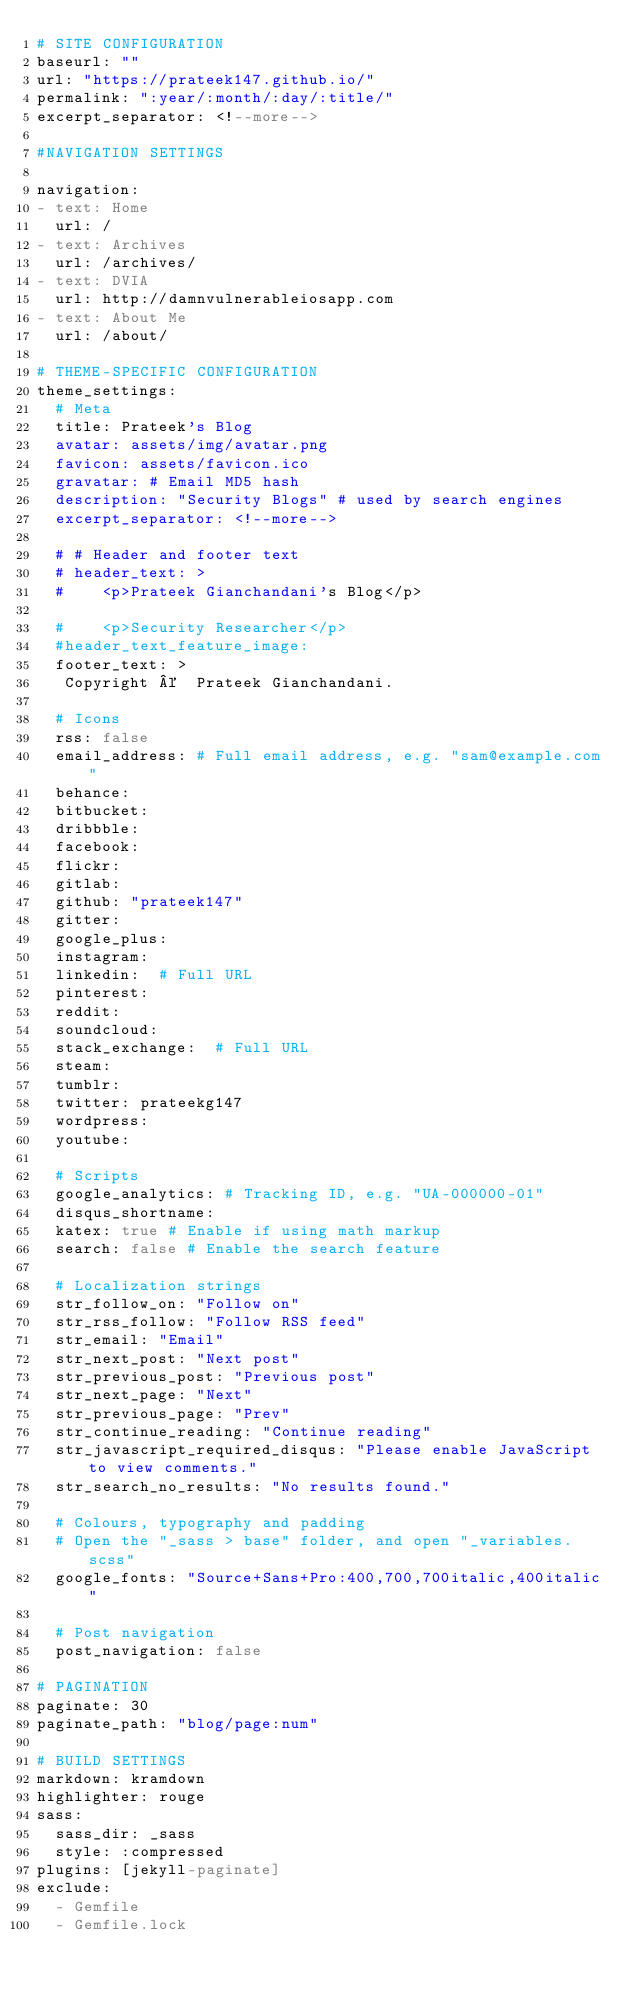<code> <loc_0><loc_0><loc_500><loc_500><_YAML_># SITE CONFIGURATION
baseurl: ""
url: "https://prateek147.github.io/"
permalink: ":year/:month/:day/:title/"
excerpt_separator: <!--more-->

#NAVIGATION SETTINGS

navigation:
- text: Home
  url: /
- text: Archives
  url: /archives/
- text: DVIA
  url: http://damnvulnerableiosapp.com
- text: About Me
  url: /about/

# THEME-SPECIFIC CONFIGURATION
theme_settings:
  # Meta
  title: Prateek's Blog
  avatar: assets/img/avatar.png
  favicon: assets/favicon.ico
  gravatar: # Email MD5 hash
  description: "Security Blogs" # used by search engines
  excerpt_separator: <!--more-->

  # # Header and footer text
  # header_text: >
  #    <p>Prateek Gianchandani's Blog</p>

  #    <p>Security Researcher</p>
  #header_text_feature_image:
  footer_text: >
   Copyright ©  Prateek Gianchandani.

  # Icons
  rss: false
  email_address: # Full email address, e.g. "sam@example.com"
  behance:
  bitbucket:
  dribbble:
  facebook:
  flickr:
  gitlab:
  github: "prateek147"
  gitter:
  google_plus:
  instagram:
  linkedin:  # Full URL
  pinterest:
  reddit:
  soundcloud:
  stack_exchange:  # Full URL
  steam:
  tumblr:
  twitter: prateekg147
  wordpress:
  youtube:

  # Scripts
  google_analytics: # Tracking ID, e.g. "UA-000000-01"
  disqus_shortname:
  katex: true # Enable if using math markup
  search: false # Enable the search feature

  # Localization strings
  str_follow_on: "Follow on"
  str_rss_follow: "Follow RSS feed"
  str_email: "Email"
  str_next_post: "Next post"
  str_previous_post: "Previous post"
  str_next_page: "Next"
  str_previous_page: "Prev"
  str_continue_reading: "Continue reading"
  str_javascript_required_disqus: "Please enable JavaScript to view comments."
  str_search_no_results: "No results found."

  # Colours, typography and padding
  # Open the "_sass > base" folder, and open "_variables.scss"
  google_fonts: "Source+Sans+Pro:400,700,700italic,400italic"

  # Post navigation
  post_navigation: false

# PAGINATION
paginate: 30
paginate_path: "blog/page:num"

# BUILD SETTINGS
markdown: kramdown
highlighter: rouge
sass:
  sass_dir: _sass
  style: :compressed
plugins: [jekyll-paginate]
exclude:
  - Gemfile
  - Gemfile.lock
</code> 